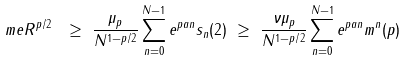Convert formula to latex. <formula><loc_0><loc_0><loc_500><loc_500>\ m e R ^ { p / 2 } \ & \geq \ \frac { \mu _ { p } } { N ^ { 1 - p / 2 } } \sum _ { n = 0 } ^ { N - 1 } e ^ { p a n } s _ { n } ( 2 ) \ \geq \ \frac { \nu \mu _ { p } } { N ^ { 1 - p / 2 } } \sum _ { n = 0 } ^ { N - 1 } e ^ { p a n } m ^ { n } ( p )</formula> 